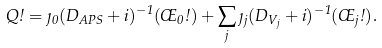Convert formula to latex. <formula><loc_0><loc_0><loc_500><loc_500>Q \omega = \eta _ { 0 } ( D _ { A P S } + i ) ^ { - 1 } ( \phi _ { 0 } \omega ) + \sum _ { j } \eta _ { j } ( D _ { V _ { j } } + i ) ^ { - 1 } ( \phi _ { j } \omega ) .</formula> 